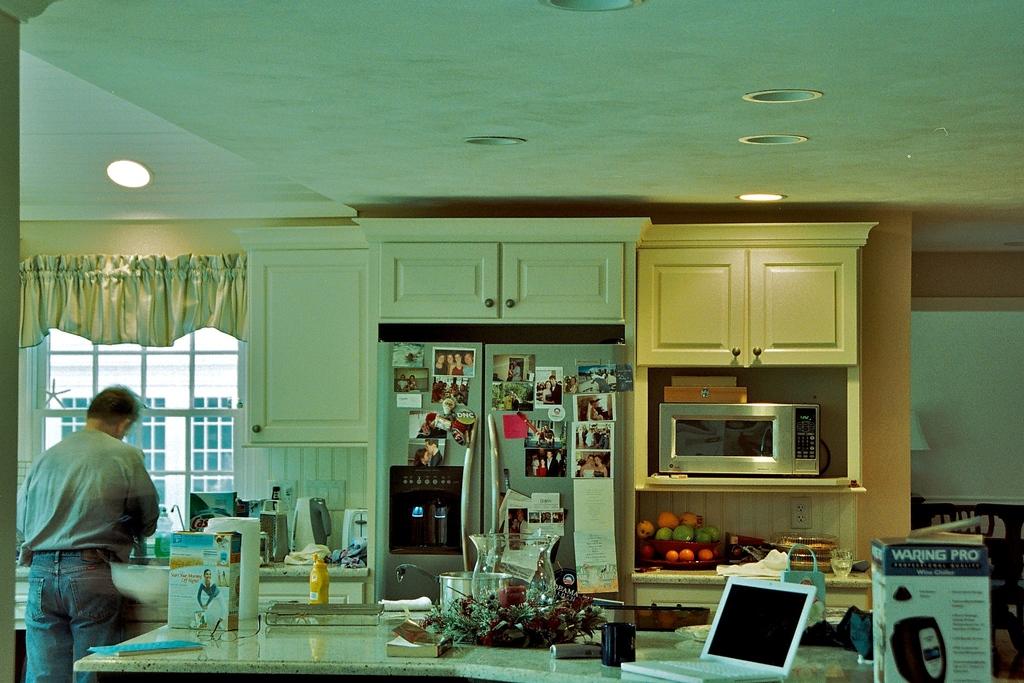What product is in the box on the right?
Provide a short and direct response. Waring pro. 